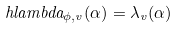<formula> <loc_0><loc_0><loc_500><loc_500>\ h l a m b d a _ { \phi , v } ( \alpha ) = \lambda _ { v } ( \alpha )</formula> 